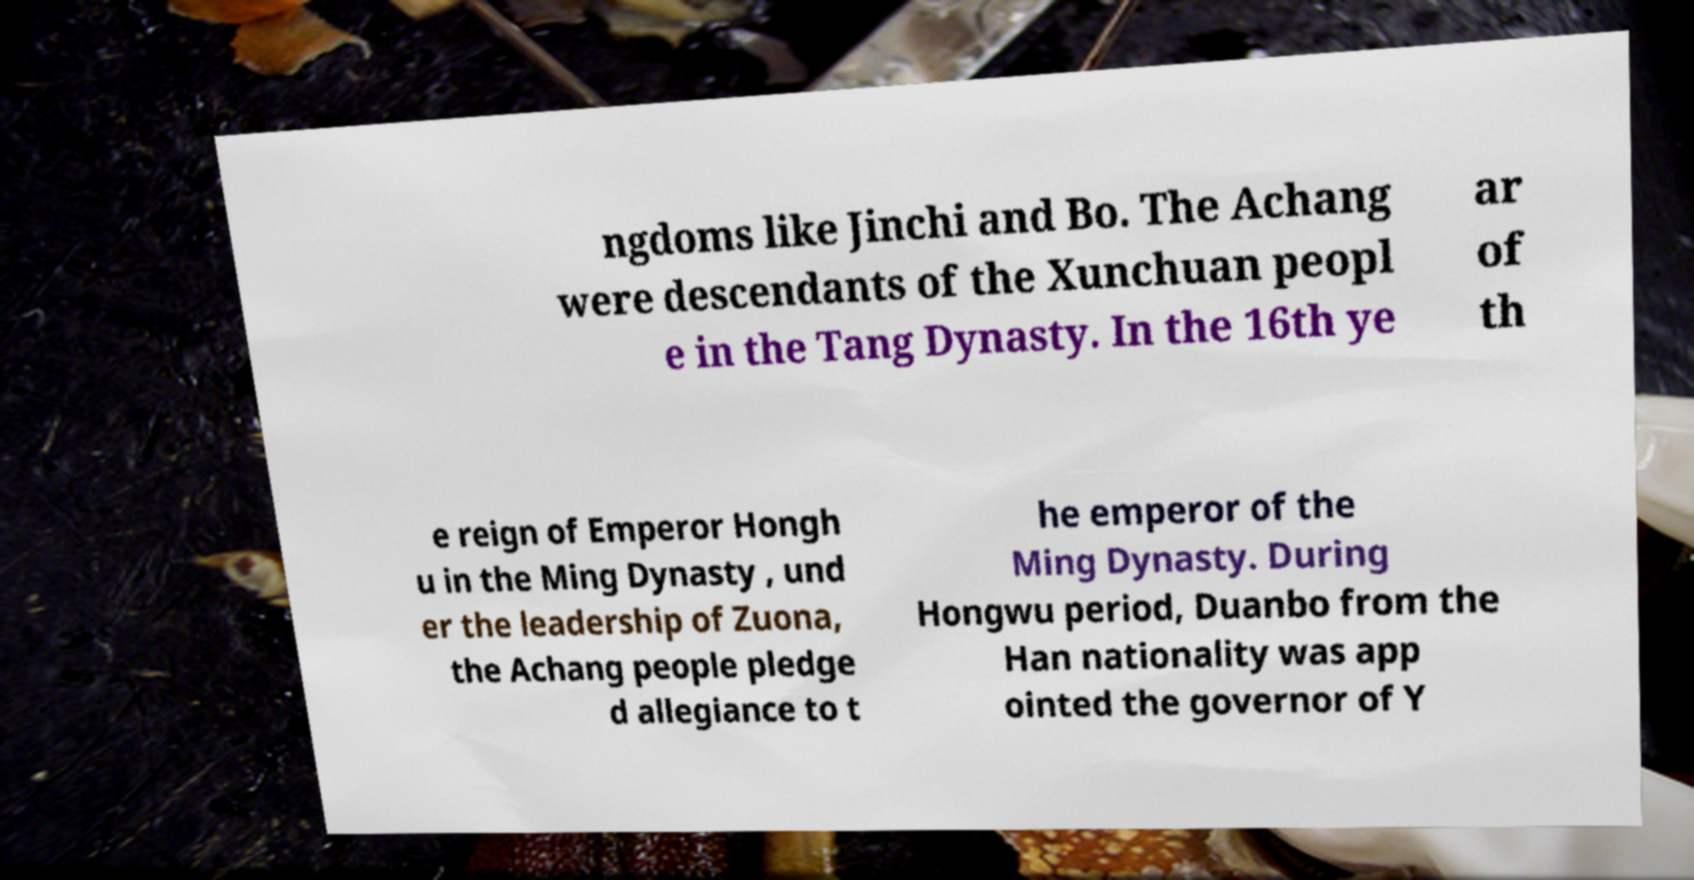I need the written content from this picture converted into text. Can you do that? ngdoms like Jinchi and Bo. The Achang were descendants of the Xunchuan peopl e in the Tang Dynasty. In the 16th ye ar of th e reign of Emperor Hongh u in the Ming Dynasty , und er the leadership of Zuona, the Achang people pledge d allegiance to t he emperor of the Ming Dynasty. During Hongwu period, Duanbo from the Han nationality was app ointed the governor of Y 